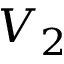Convert formula to latex. <formula><loc_0><loc_0><loc_500><loc_500>V _ { 2 }</formula> 